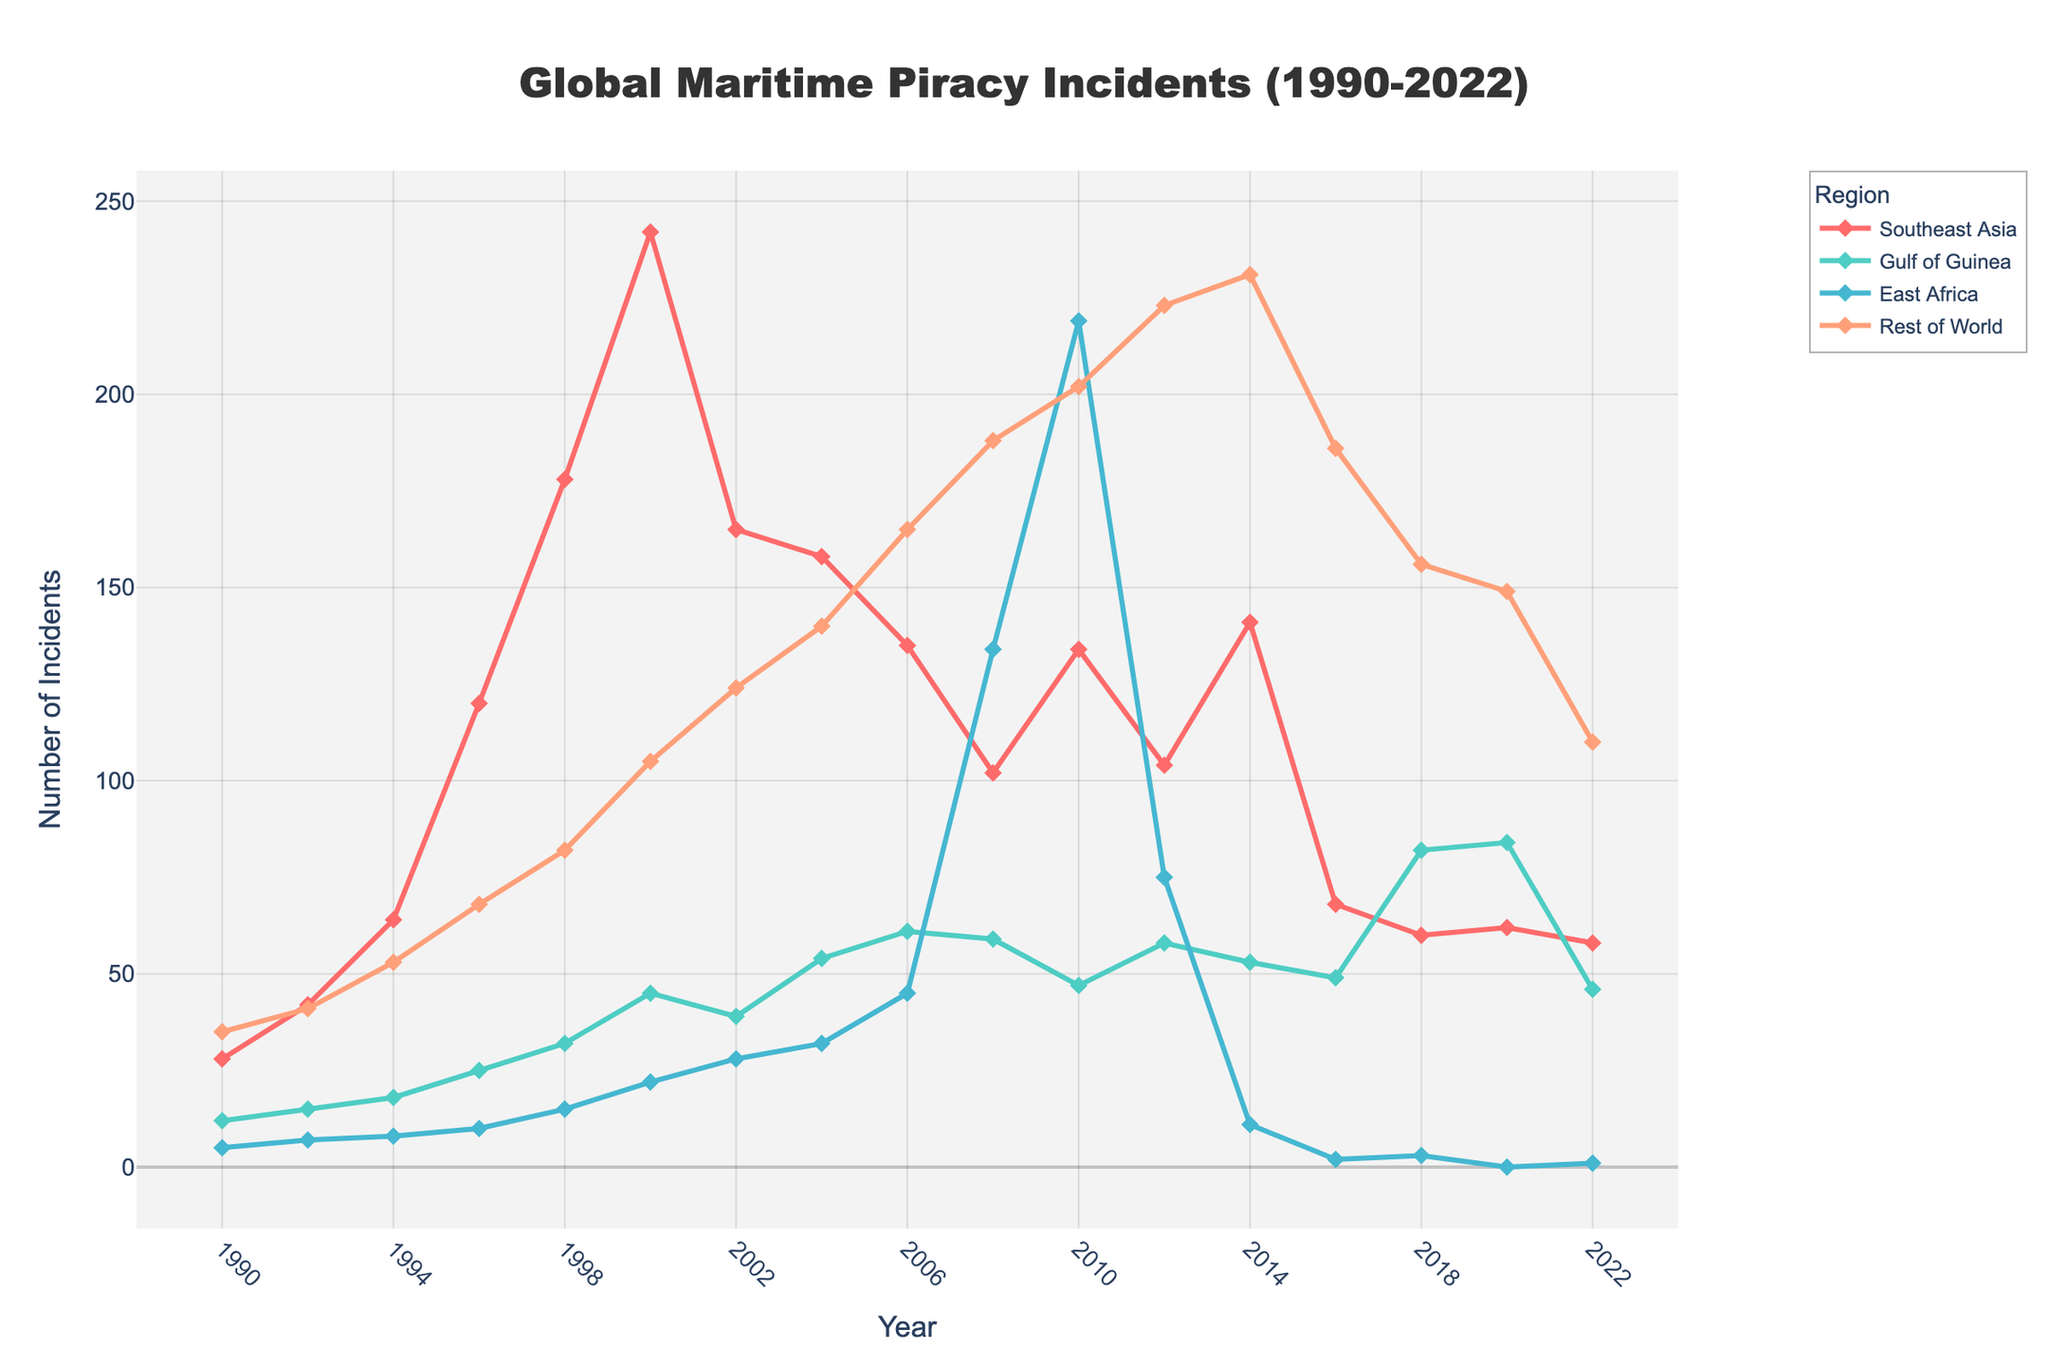what is the overall trend in Southeast Asia's maritime piracy incidents from 1990 to 2022? Observing each point for Southeast Asia over the years from the chart, we see a clear increase in incidents reaching a peak around 2000, followed by an overall decline towards 2022.
Answer: Increasing until 2000, then decreasing which region had the highest number of piracy incidents in the year 2008? By comparing the heights of the markers for each region at the year 2008, East Africa stands out as the region with the highest count.
Answer: East Africa in which year did the Gulf of Guinea experience the highest number of piracy incidents? By looking at the peaks of the line representing the Gulf of Guinea, the highest point is in the year 2020.
Answer: 2020 how did the incidents in the 'Rest of World' region change from 2000 to 2010? Examining the line for 'Rest of World', we note that the incidents increased from 105 in 2000 to 202 in 2010.
Answer: Increased are there any regions where piracy incidents reduced to zero? If so, which region and when? Observing the line chart, East Africa's incidents dropped to zero in 2020.
Answer: East Africa in 2020 compare the number of incidents in Southeast Asia and the Gulf of Guinea in 2002. Which region had more incidents and by how much? From the chart, Southeast Asia had 165 incidents and Gulf of Guinea had 39 in 2002. The difference is 126.
Answer: Southeast Asia by 126 what was the difference in the number of incidents in East Africa between 2008 and 2010? East Africa had 134 incidents in 2008 and 219 in 2010. The increase is 219 - 134 = 85.
Answer: 85 how did the number of incidents in the 'Rest of World' region change from its minimum to maximum value? 'Rest of World' had its lowest value in 1990 with 35 incidents and the highest value in 2014 with 231 incidents. The change is 231 - 35 = 196.
Answer: Increased by 196 among all the years provided, which had the lowest number of total piracy incidents globally, and what is the value? By summing up the incidents across all regions for each year, 1990 had the lowest total with 28 + 12 + 5 + 35 = 80 incidents.
Answer: 1990 with 80 incidents 